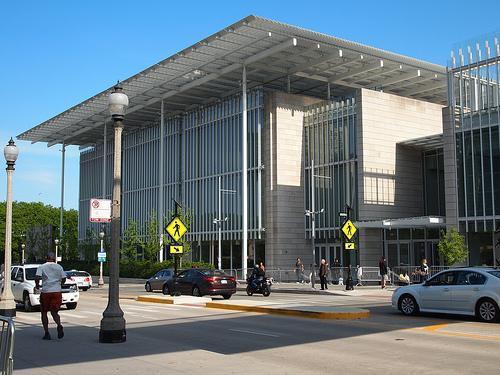How many people are in the picture?
Give a very brief answer. 9. 